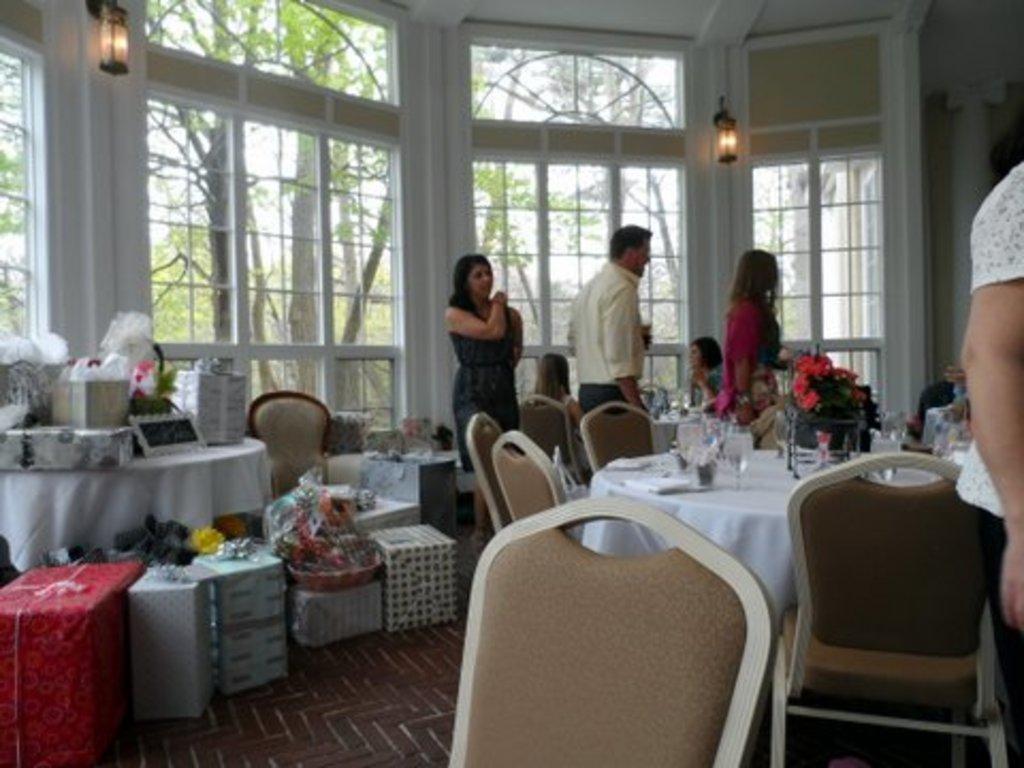In one or two sentences, can you explain what this image depicts? this picture shows three people are standing and couple of the much seated on the chairs and we see few glasses on the table and few packed gifts on the side and we see couple of trees from the window 